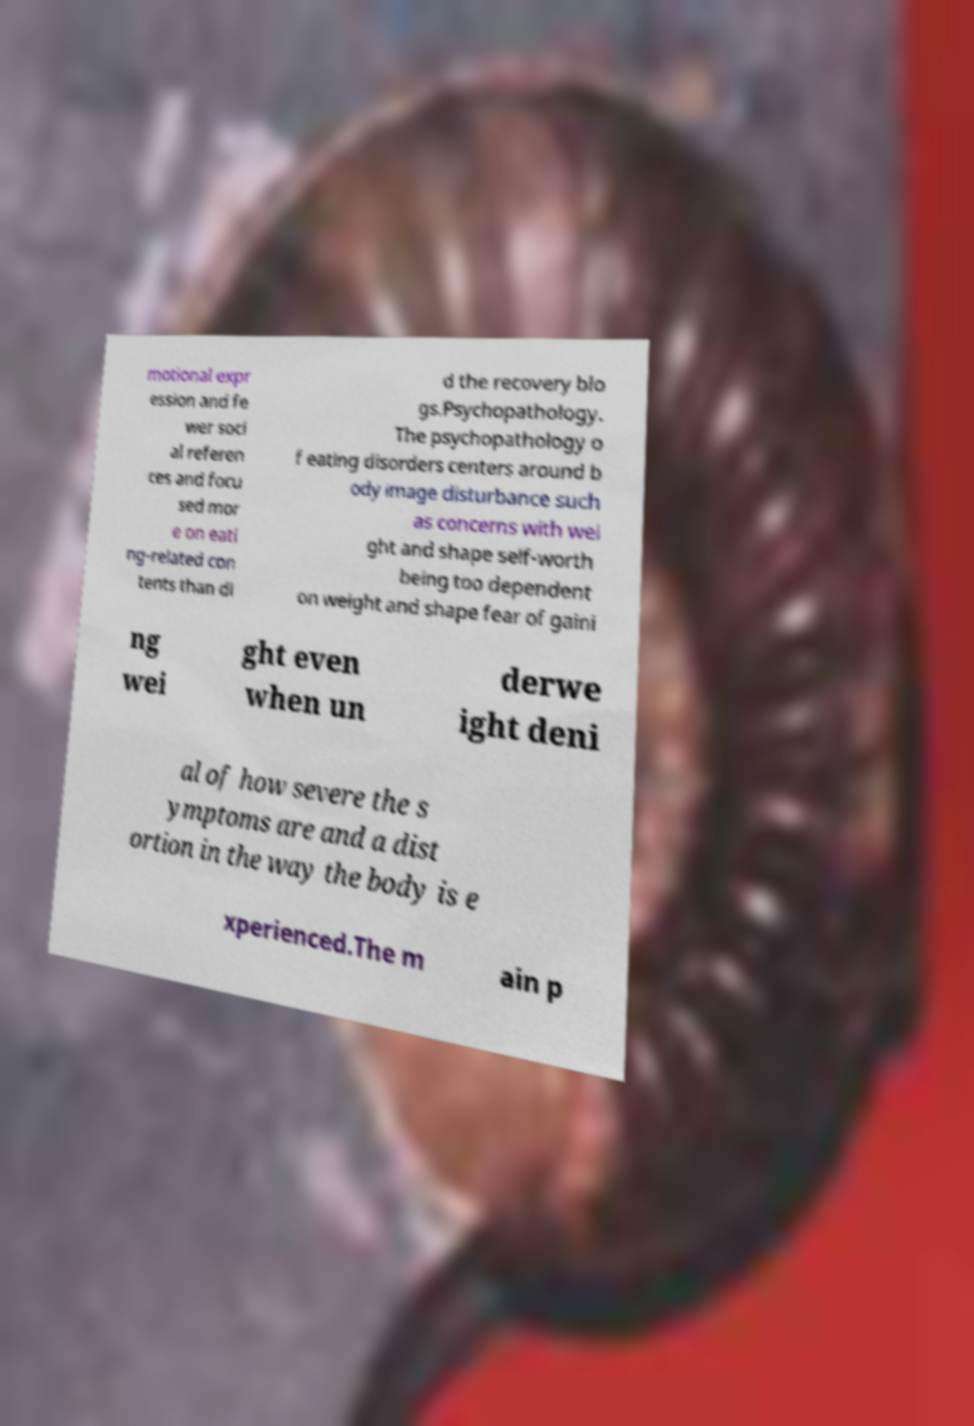Can you read and provide the text displayed in the image?This photo seems to have some interesting text. Can you extract and type it out for me? motional expr ession and fe wer soci al referen ces and focu sed mor e on eati ng-related con tents than di d the recovery blo gs.Psychopathology. The psychopathology o f eating disorders centers around b ody image disturbance such as concerns with wei ght and shape self-worth being too dependent on weight and shape fear of gaini ng wei ght even when un derwe ight deni al of how severe the s ymptoms are and a dist ortion in the way the body is e xperienced.The m ain p 